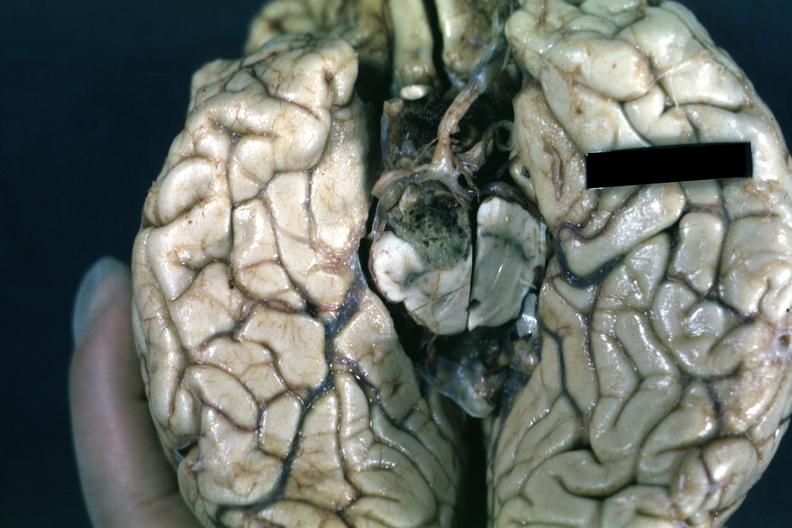what is present?
Answer the question using a single word or phrase. Endocrine 